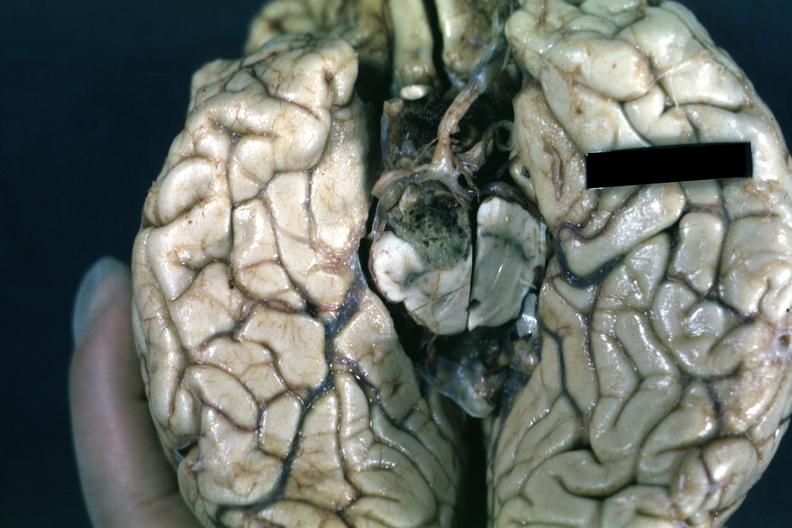what is present?
Answer the question using a single word or phrase. Endocrine 